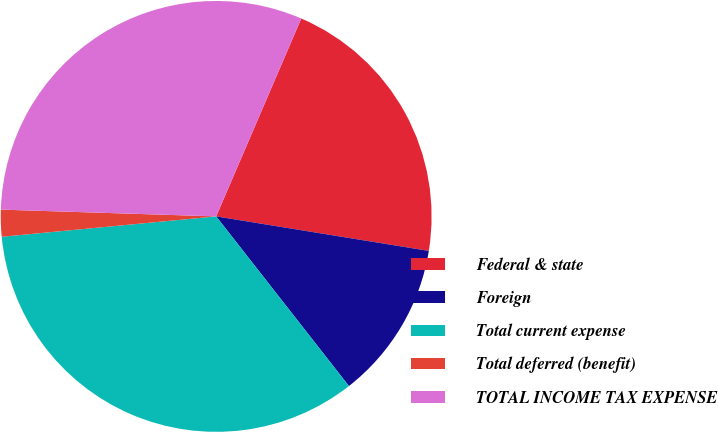<chart> <loc_0><loc_0><loc_500><loc_500><pie_chart><fcel>Federal & state<fcel>Foreign<fcel>Total current expense<fcel>Total deferred (benefit)<fcel>TOTAL INCOME TAX EXPENSE<nl><fcel>21.1%<fcel>11.87%<fcel>34.06%<fcel>2.01%<fcel>30.96%<nl></chart> 